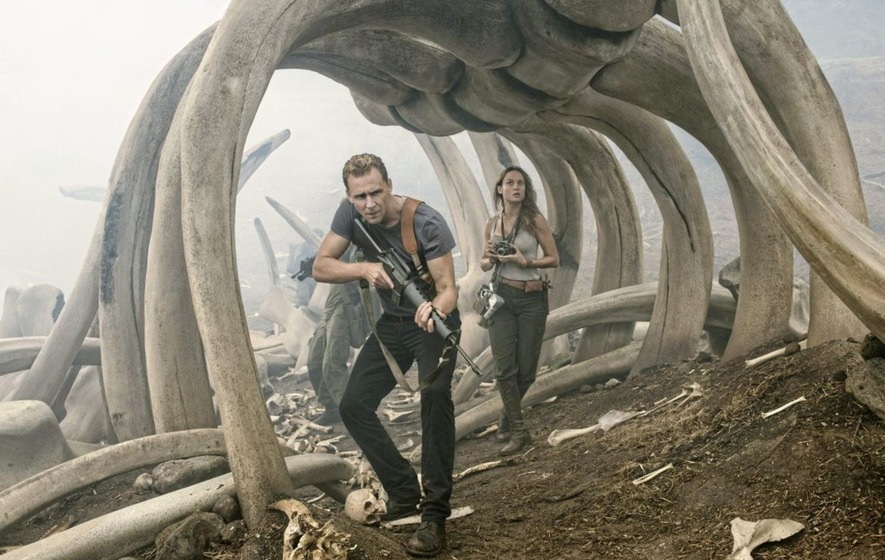Create a detailed backstory for the location they are in. The characters find themselves in an ancient burial ground known as the Valley of the Titans. Long ago, this place was a thriving habitat for colossal creatures that roamed the earth before the dawn of humans. The enormous bones that now form eerie archways were once the skeletons of majestic beasts that were the apex predators of their time. The valley was hidden by a veil of perpetual mist, preservation of this graveyard untouched by modern civilization for eons. Legends spoke of an ancient guardian, a creature of immense power that still watched over the remains, ensuring that the secrets and power of the Titans were never discovered by the unworthy. This guardian, believed to be more myth than reality, is rumored to still patrol the valley, protecting it from any who dare to venture too close. 